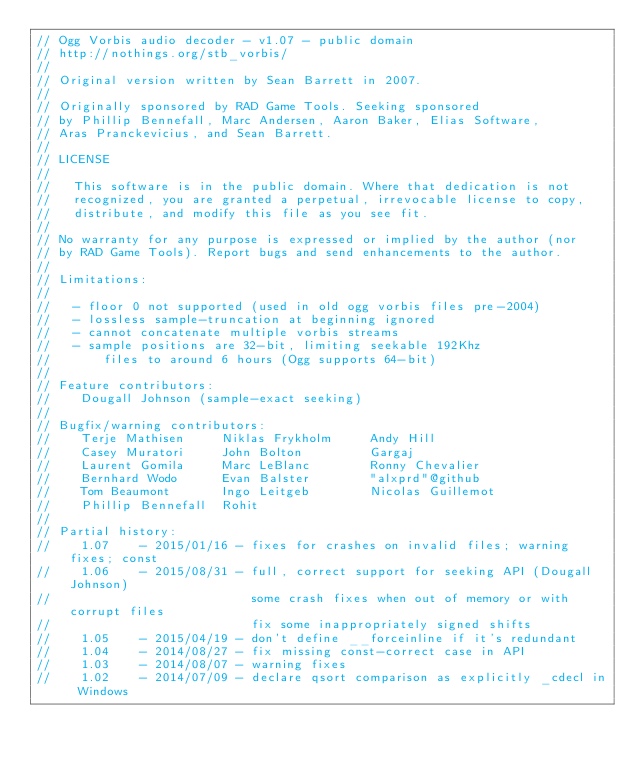<code> <loc_0><loc_0><loc_500><loc_500><_C_>// Ogg Vorbis audio decoder - v1.07 - public domain
// http://nothings.org/stb_vorbis/
//
// Original version written by Sean Barrett in 2007.
//
// Originally sponsored by RAD Game Tools. Seeking sponsored
// by Phillip Bennefall, Marc Andersen, Aaron Baker, Elias Software,
// Aras Pranckevicius, and Sean Barrett.
//
// LICENSE
//
//   This software is in the public domain. Where that dedication is not
//   recognized, you are granted a perpetual, irrevocable license to copy,
//   distribute, and modify this file as you see fit.
//
// No warranty for any purpose is expressed or implied by the author (nor
// by RAD Game Tools). Report bugs and send enhancements to the author.
//
// Limitations:
//
//   - floor 0 not supported (used in old ogg vorbis files pre-2004)
//   - lossless sample-truncation at beginning ignored
//   - cannot concatenate multiple vorbis streams
//   - sample positions are 32-bit, limiting seekable 192Khz
//       files to around 6 hours (Ogg supports 64-bit)
//
// Feature contributors:
//    Dougall Johnson (sample-exact seeking)
//
// Bugfix/warning contributors:
//    Terje Mathisen     Niklas Frykholm     Andy Hill
//    Casey Muratori     John Bolton         Gargaj
//    Laurent Gomila     Marc LeBlanc        Ronny Chevalier
//    Bernhard Wodo      Evan Balster        "alxprd"@github
//    Tom Beaumont       Ingo Leitgeb        Nicolas Guillemot
//    Phillip Bennefall  Rohit
//
// Partial history:
//    1.07    - 2015/01/16 - fixes for crashes on invalid files; warning fixes; const
//    1.06    - 2015/08/31 - full, correct support for seeking API (Dougall Johnson)
//                           some crash fixes when out of memory or with corrupt files
//                           fix some inappropriately signed shifts
//    1.05    - 2015/04/19 - don't define __forceinline if it's redundant
//    1.04    - 2014/08/27 - fix missing const-correct case in API
//    1.03    - 2014/08/07 - warning fixes
//    1.02    - 2014/07/09 - declare qsort comparison as explicitly _cdecl in Windows</code> 